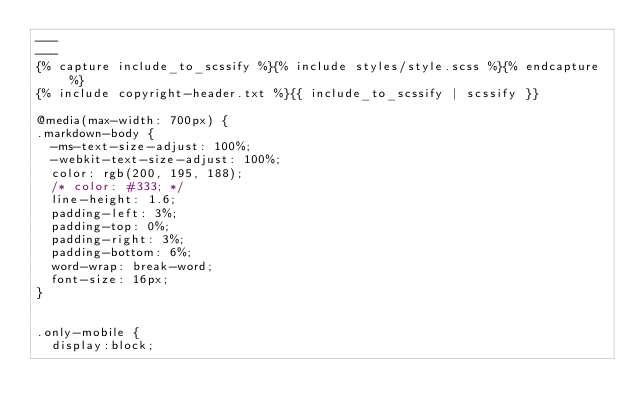<code> <loc_0><loc_0><loc_500><loc_500><_CSS_>---
---
{% capture include_to_scssify %}{% include styles/style.scss %}{% endcapture %}
{% include copyright-header.txt %}{{ include_to_scssify | scssify }}

@media(max-width: 700px) {
.markdown-body {
  -ms-text-size-adjust: 100%;
  -webkit-text-size-adjust: 100%;
  color: rgb(200, 195, 188);
  /* color: #333; */
  line-height: 1.6;
  padding-left: 3%;
  padding-top: 0%;
  padding-right: 3%;
  padding-bottom: 6%;
  word-wrap: break-word;
  font-size: 16px;
}


.only-mobile {
  display:block;</code> 